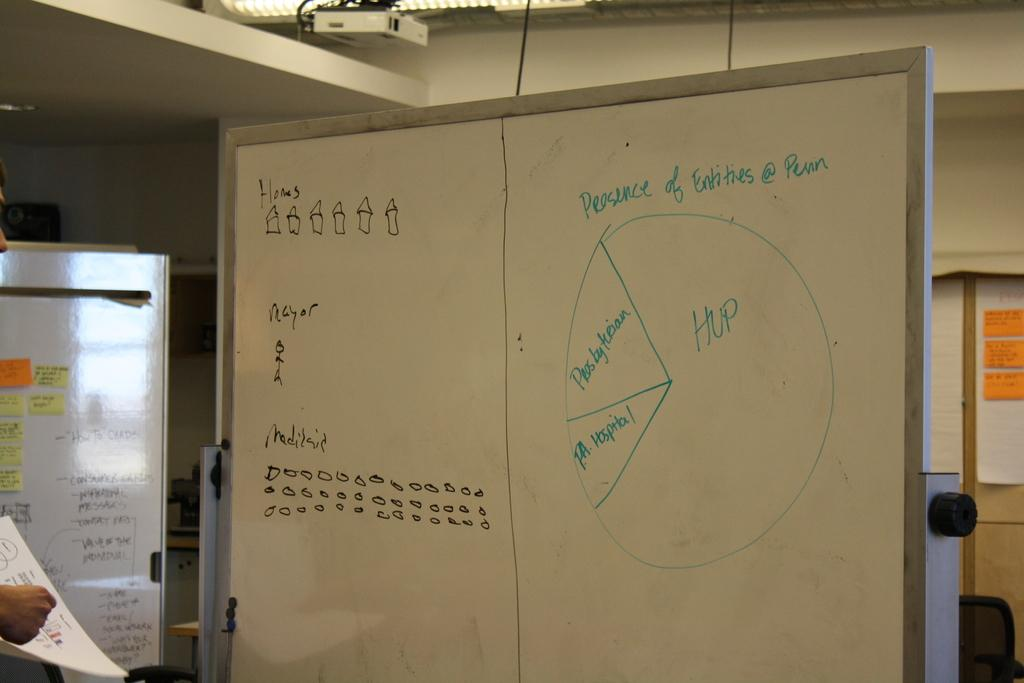<image>
Present a compact description of the photo's key features. Whiteboard with pie chart of Presence of Entities @ Penn, including HUP, Presbyterian, and PA Hospital represented. 